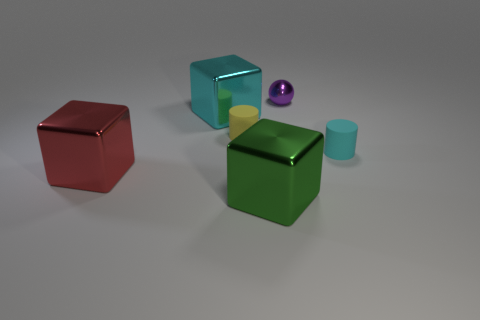Add 3 big shiny things. How many objects exist? 9 Subtract all cyan cubes. How many cubes are left? 2 Subtract 3 cubes. How many cubes are left? 0 Add 5 tiny cyan cylinders. How many tiny cyan cylinders exist? 6 Subtract 0 purple blocks. How many objects are left? 6 Subtract all spheres. How many objects are left? 5 Subtract all red spheres. Subtract all red cubes. How many spheres are left? 1 Subtract all blue cylinders. How many yellow cubes are left? 0 Subtract all tiny red blocks. Subtract all small matte objects. How many objects are left? 4 Add 3 rubber cylinders. How many rubber cylinders are left? 5 